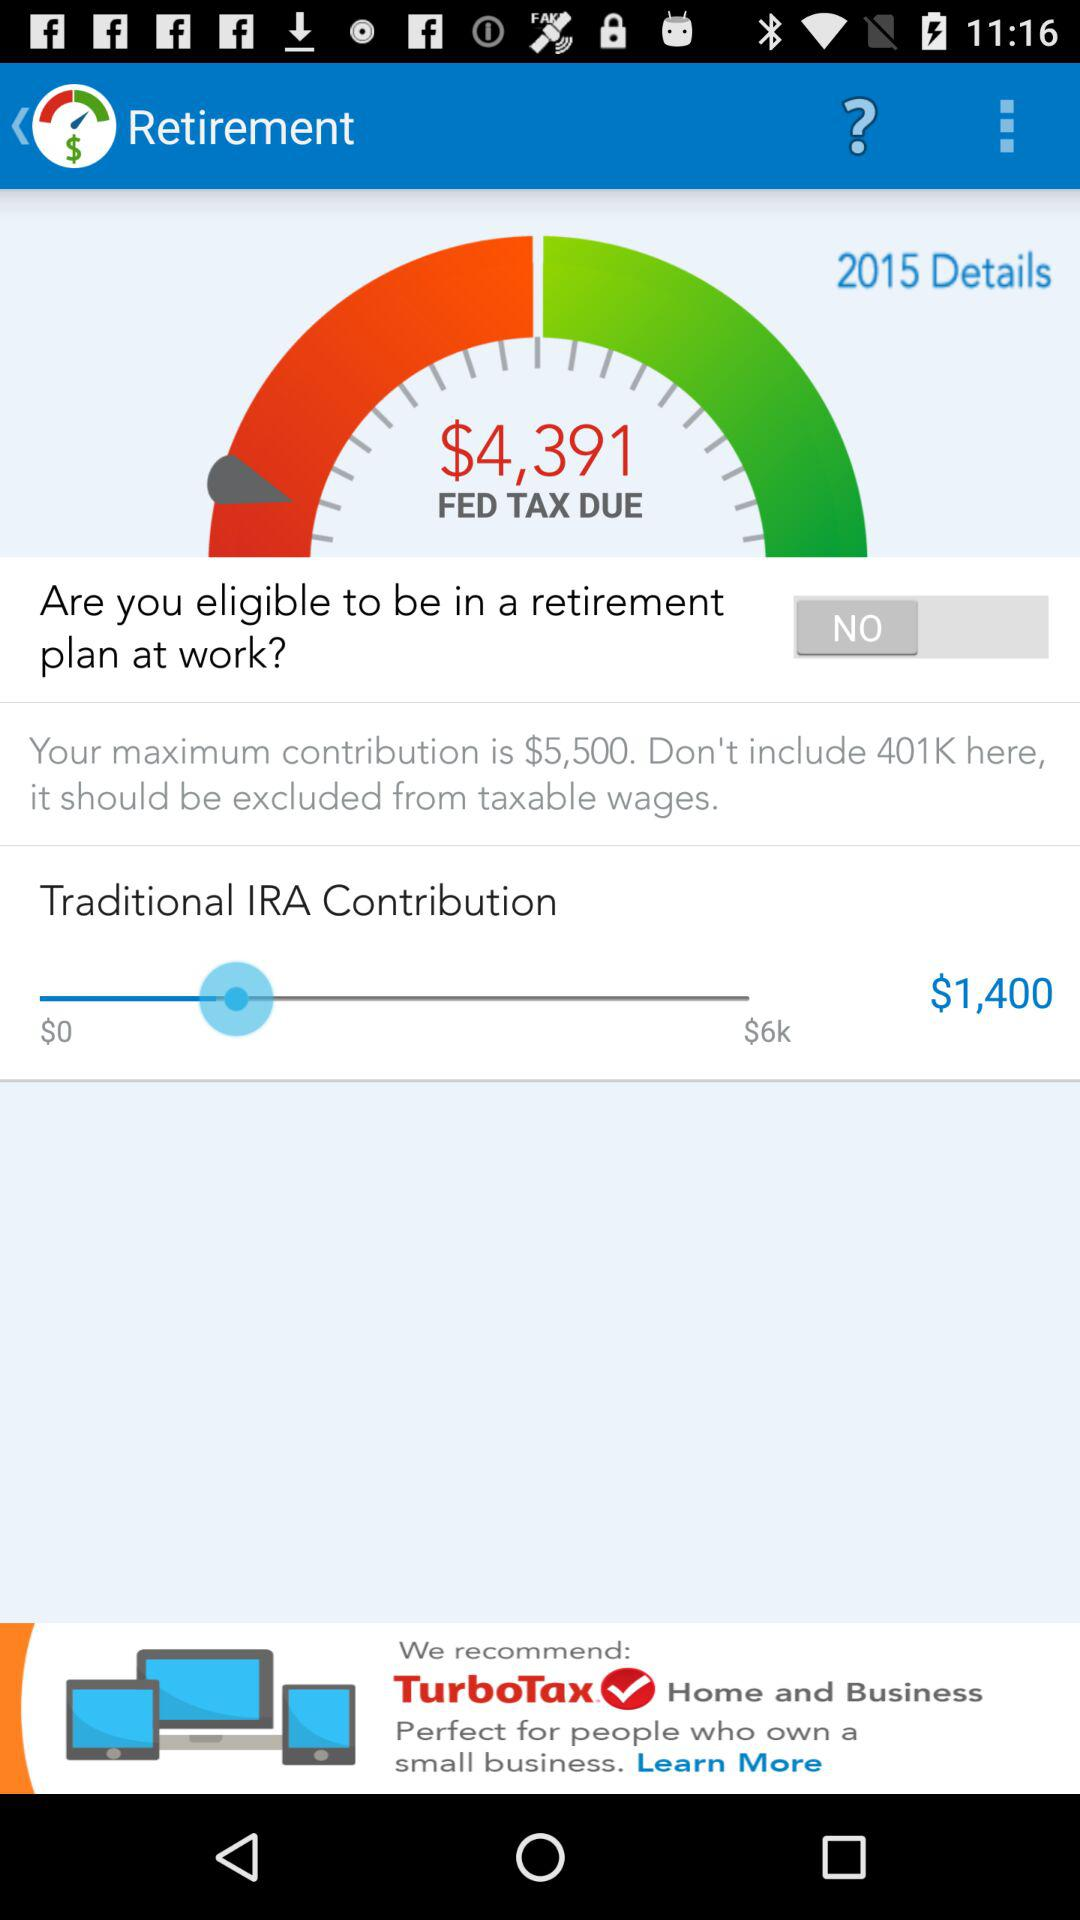How much does the user have contributed to their traditional IRA?
Answer the question using a single word or phrase. $1,400 